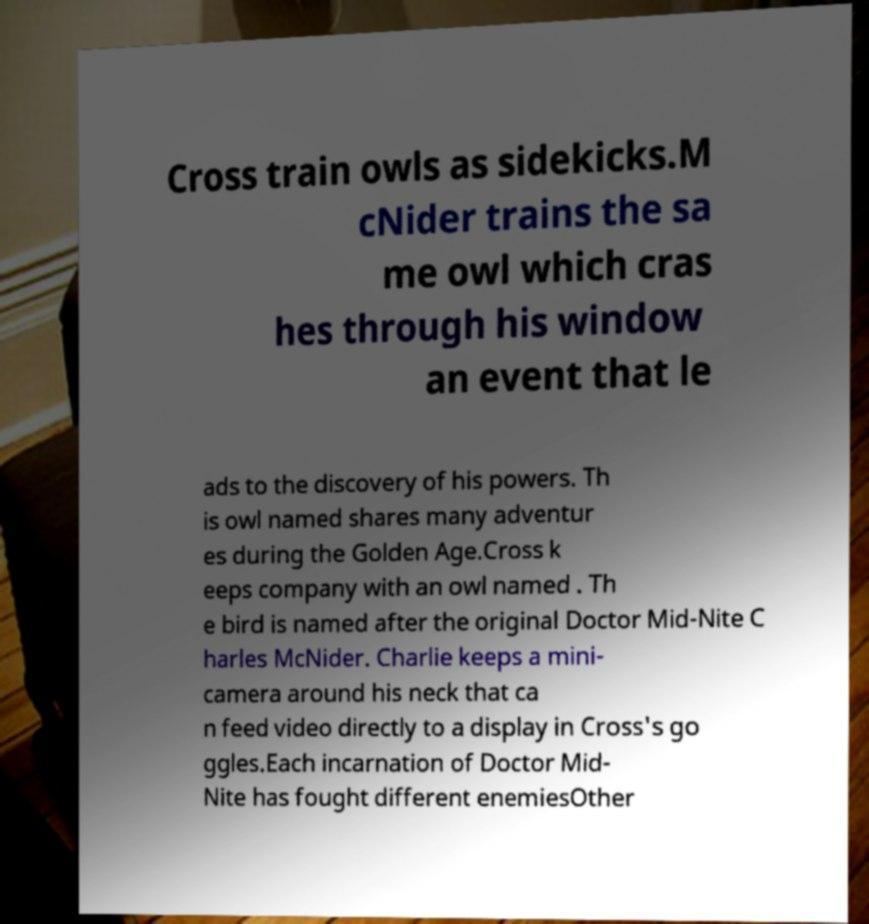For documentation purposes, I need the text within this image transcribed. Could you provide that? Cross train owls as sidekicks.M cNider trains the sa me owl which cras hes through his window an event that le ads to the discovery of his powers. Th is owl named shares many adventur es during the Golden Age.Cross k eeps company with an owl named . Th e bird is named after the original Doctor Mid-Nite C harles McNider. Charlie keeps a mini- camera around his neck that ca n feed video directly to a display in Cross's go ggles.Each incarnation of Doctor Mid- Nite has fought different enemiesOther 